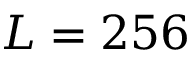<formula> <loc_0><loc_0><loc_500><loc_500>L = 2 5 6</formula> 